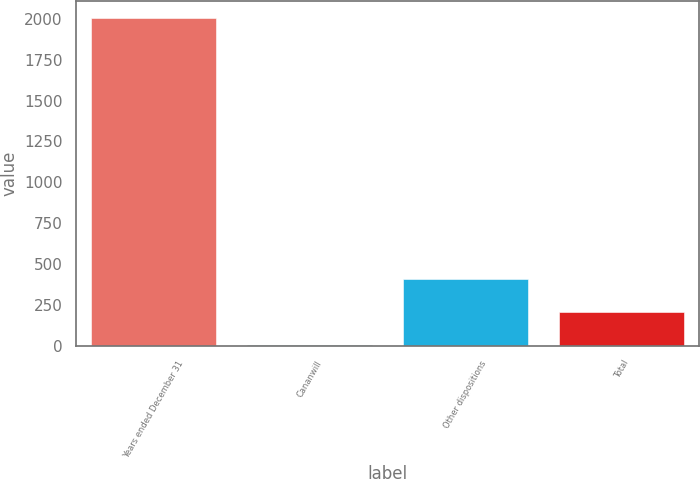Convert chart. <chart><loc_0><loc_0><loc_500><loc_500><bar_chart><fcel>Years ended December 31<fcel>Cananwill<fcel>Other dispositions<fcel>Total<nl><fcel>2008<fcel>5<fcel>405.6<fcel>205.3<nl></chart> 